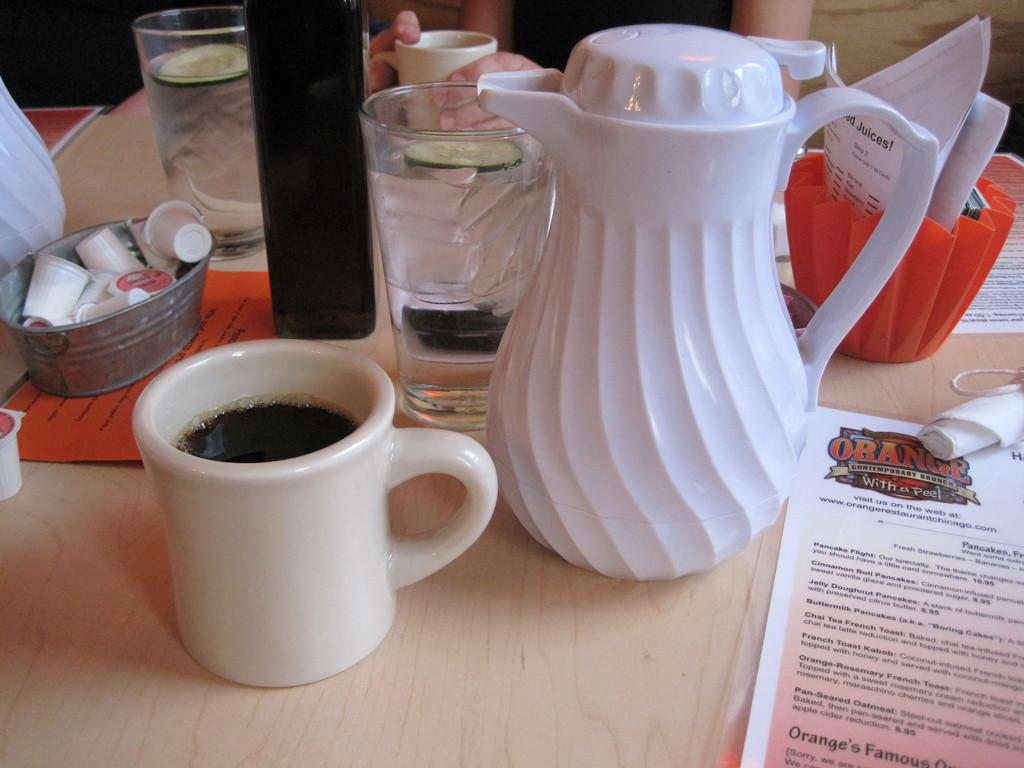What is in the cup that is visible in the image? There is tea in a cup in the image. What is the source of hot water for the tea? There is a kettle in the image. What is in the glass that is visible in the image? There is water in a glass in the image. What object is present that might be used for reading or writing? There is a paper in the image. What is the person in the image doing? A person is sitting in the image. What type of vegetable is visible in the image? There is a cucumber in the image. What type of eyewear is visible in the image? There are glasses in the image. What disease is the person in the image suffering from? There is no indication of any disease in the image. What type of milk is being used to make the tea in the image? There is no milk present in the image; only tea, a kettle, and water are visible. 